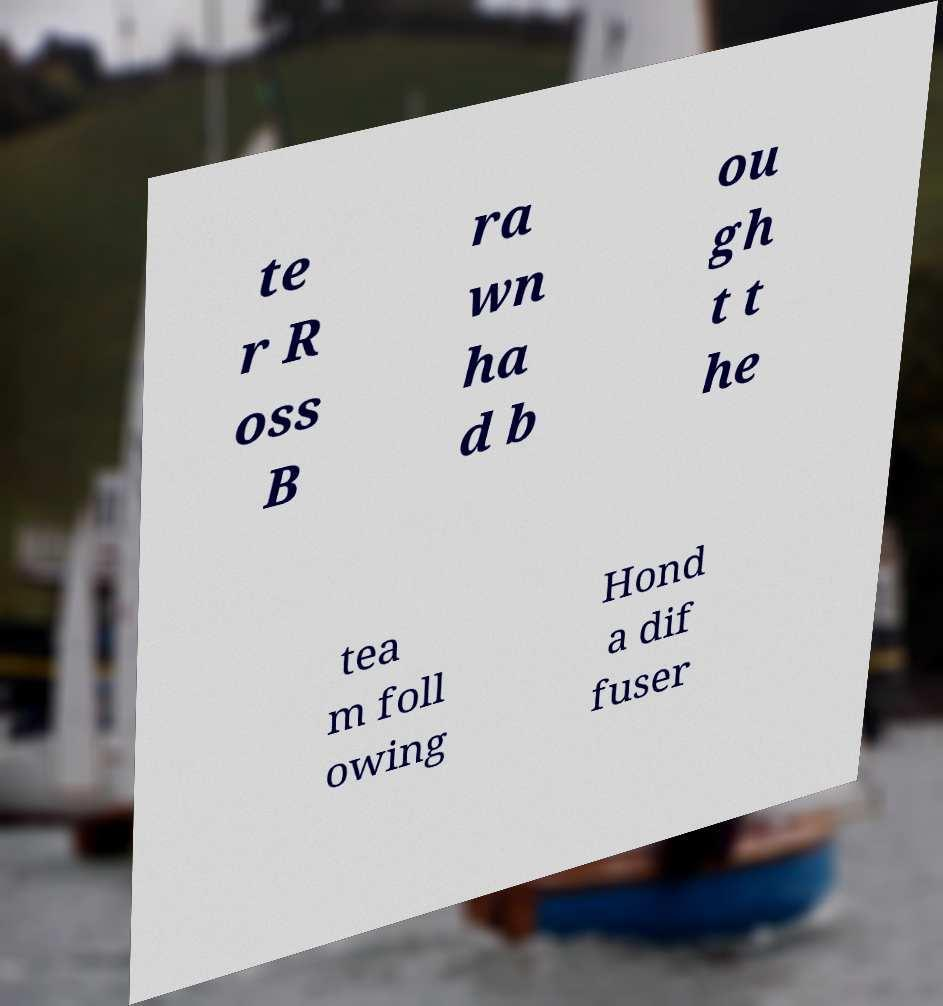I need the written content from this picture converted into text. Can you do that? te r R oss B ra wn ha d b ou gh t t he tea m foll owing Hond a dif fuser 